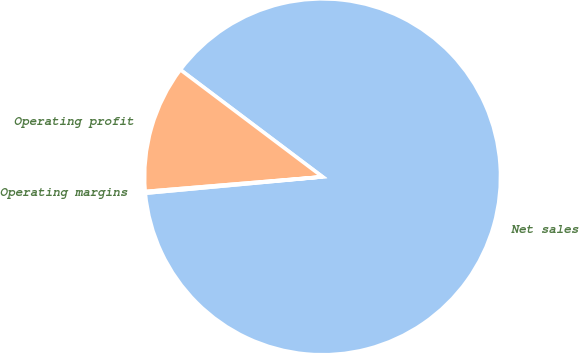<chart> <loc_0><loc_0><loc_500><loc_500><pie_chart><fcel>Net sales<fcel>Operating profit<fcel>Operating margins<nl><fcel>88.26%<fcel>11.59%<fcel>0.15%<nl></chart> 